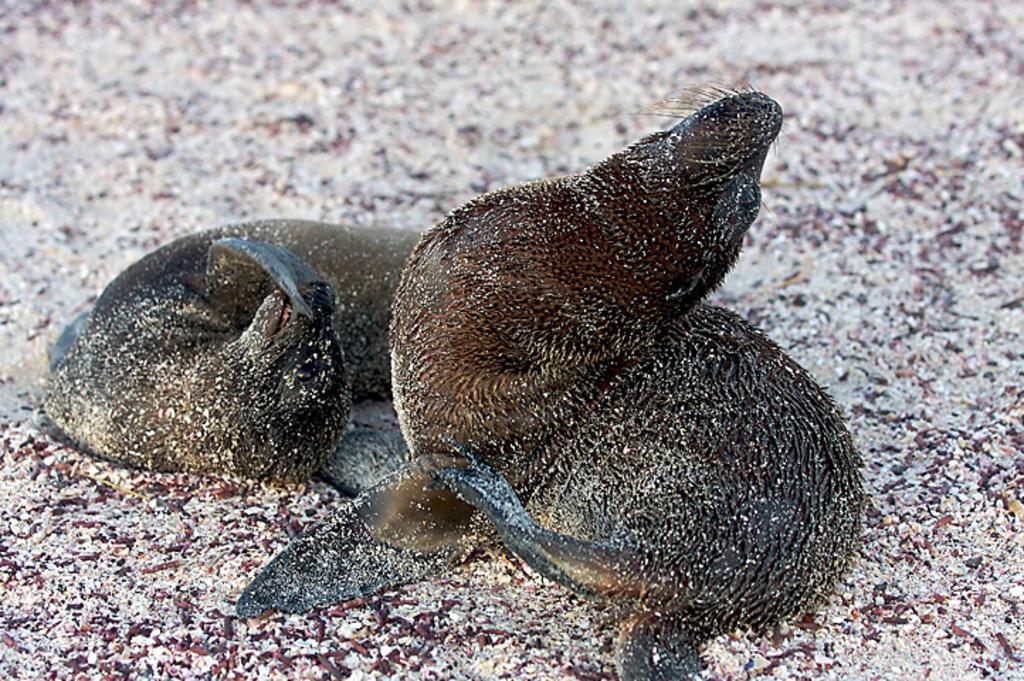Could you give a brief overview of what you see in this image? In this picture we can see two animals and some objects on a surface. 